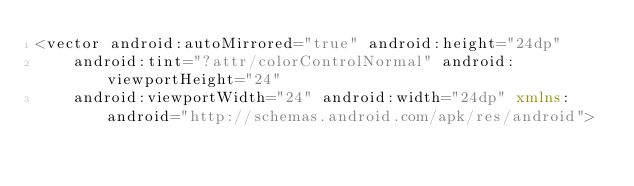<code> <loc_0><loc_0><loc_500><loc_500><_XML_><vector android:autoMirrored="true" android:height="24dp"
    android:tint="?attr/colorControlNormal" android:viewportHeight="24"
    android:viewportWidth="24" android:width="24dp" xmlns:android="http://schemas.android.com/apk/res/android"></code> 